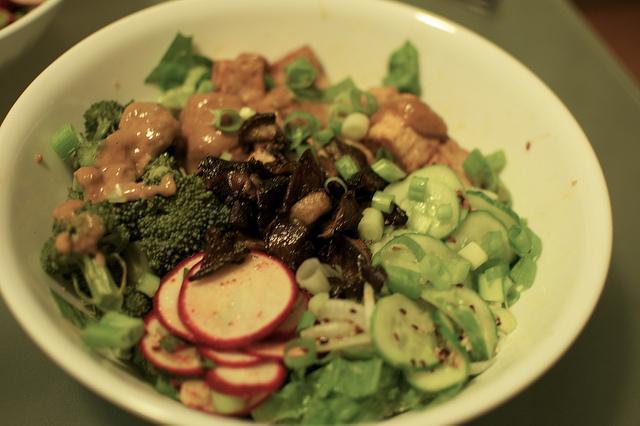What animal would most enjoy the food in the bowl?
Indicate the correct response and explain using: 'Answer: answer
Rationale: rationale.'
Options: Sheep, wolf, lion, hyena. Answer: sheep.
Rationale: A sheep would enjoy this as they are herbivores and this is full of vegetables. 